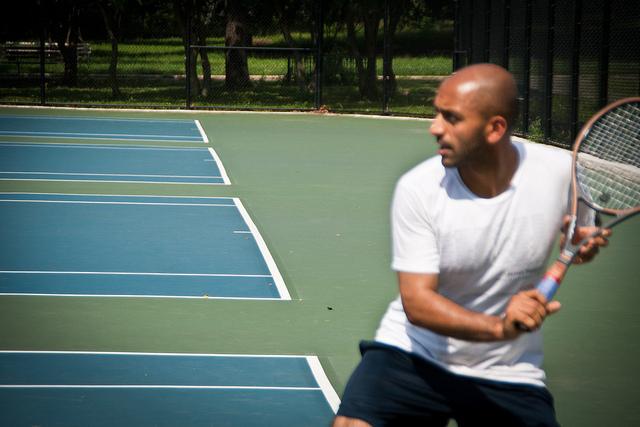Does the man have a lot of hair on his head?
Write a very short answer. No. Is this player's hair in a ponytail?
Write a very short answer. No. What sport is the man playing?
Answer briefly. Tennis. What color is the court?
Concise answer only. Blue. What color is the man's shirt?
Answer briefly. White. 